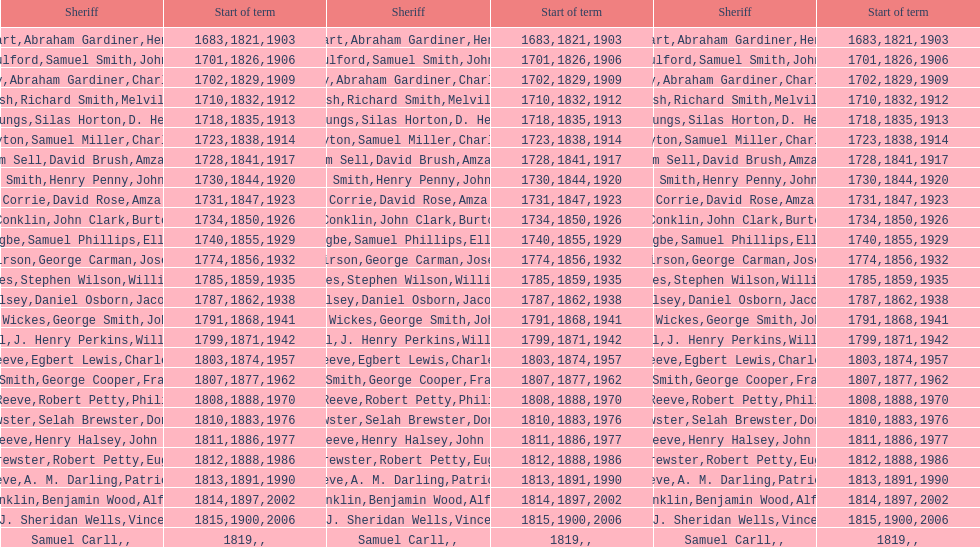Who was the sheriff preceding thomas wickes? James Muirson. 